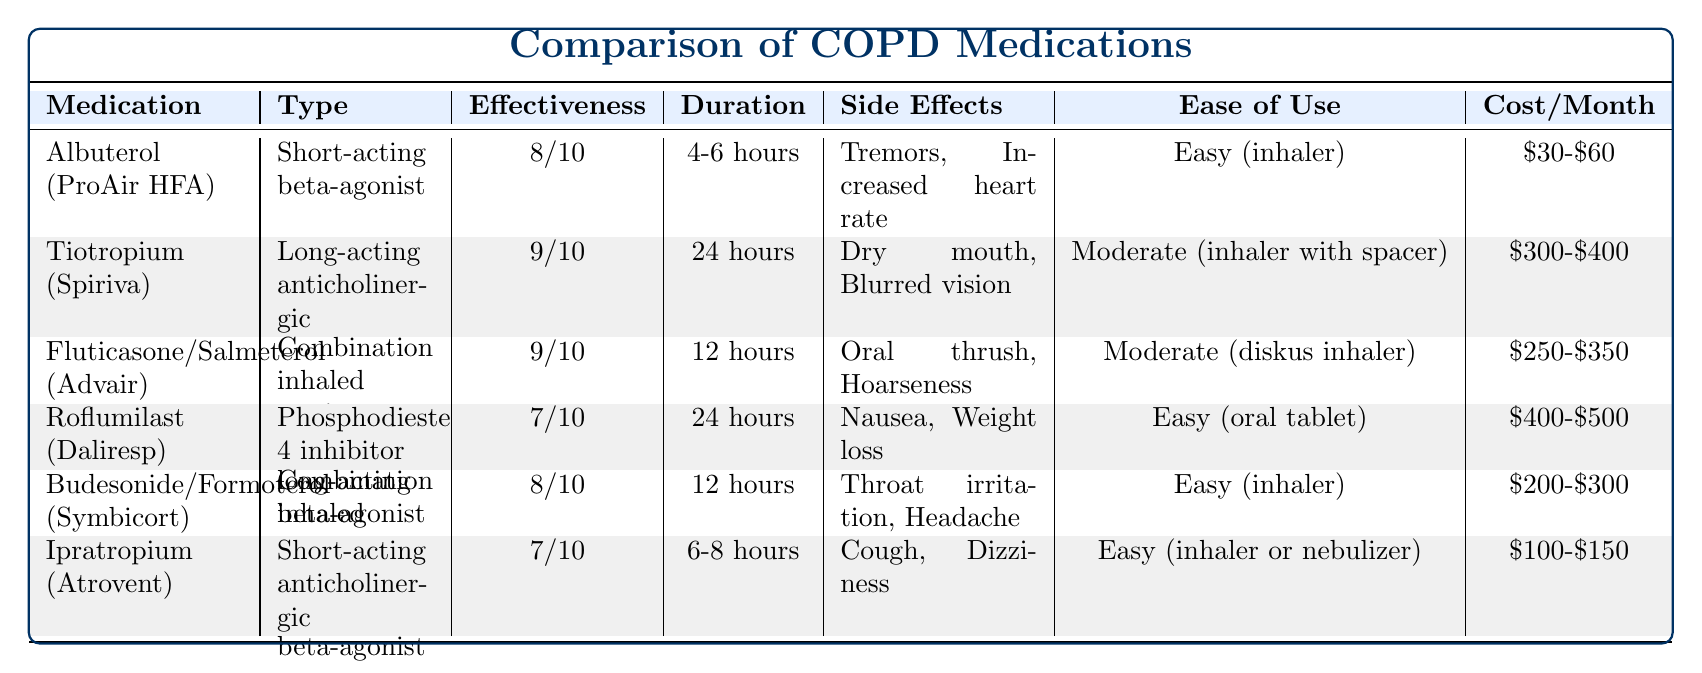What is the effectiveness rating of Tiotropium (Spiriva)? The effectiveness rating for Tiotropium is listed in the table as 9 out of 10.
Answer: 9/10 Which medication has the longest duration of action? Tiotropium (Spiriva) has the longest duration of action at 24 hours, compared to others like Albuterol and Ipratropium, which have shorter durations.
Answer: Tiotropium (Spiriva) What are the side effects of Fluticasone/Salmeterol (Advair)? The side effects for Fluticasone/Salmeterol (Advair) are listed as Oral thrush and Hoarseness in the table.
Answer: Oral thrush, Hoarseness What is the average cost per month of the medications listed? The costs per month for each medication are: $30-$60, $300-$400, $250-$350, $400-$500, $200-$300, $100-$150. Taking the average cost from the midpoints: (45 + 350 + 300 + 450 + 250 + 125) / 6 = 220
Answer: $220 Is Budesonide/Formoterol (Symbicort) easier to use than Tiotropium (Spiriva)? Budesonide/Formoterol (Symbicort) has an ease of use rating of Easy (inhaler), while Tiotropium (Spiriva) has a rating of Moderate (inhaler with spacer), indicating that Budesonide/Formoterol is indeed easier to use.
Answer: Yes Which two medications have the same effectiveness rating? Both Fluticasone/Salmeterol (Advair) and Budesonide/Formoterol (Symbicort) have an effectiveness rating of 9 out of 10 as per the table.
Answer: Fluticasone/Salmeterol (Advair) and Budesonide/Formoterol (Symbicort) Does Ipratropium (Atrovent) have a higher effectiveness than Roflumilast (Daliresp)? The effectiveness rating for Ipratropium (Atrovent) is 7 out of 10, while Roflumilast (Daliresp) has a rating of 7 as well, meaning they are equal and Ipratropium does not have a higher effectiveness.
Answer: No What is the difference in effectiveness rating between the best and worst-rated medications? The best-rated medication, Tiotropium (Spiriva) and Fluticasone/Salmeterol (Advair) both have an effectiveness rating of 9 out of 10, while the worst-rated, Roflumilast (Daliresp) and Ipratropium (Atrovent) both have a rating of 7 out of 10. The difference is 9 - 7 = 2.
Answer: 2 